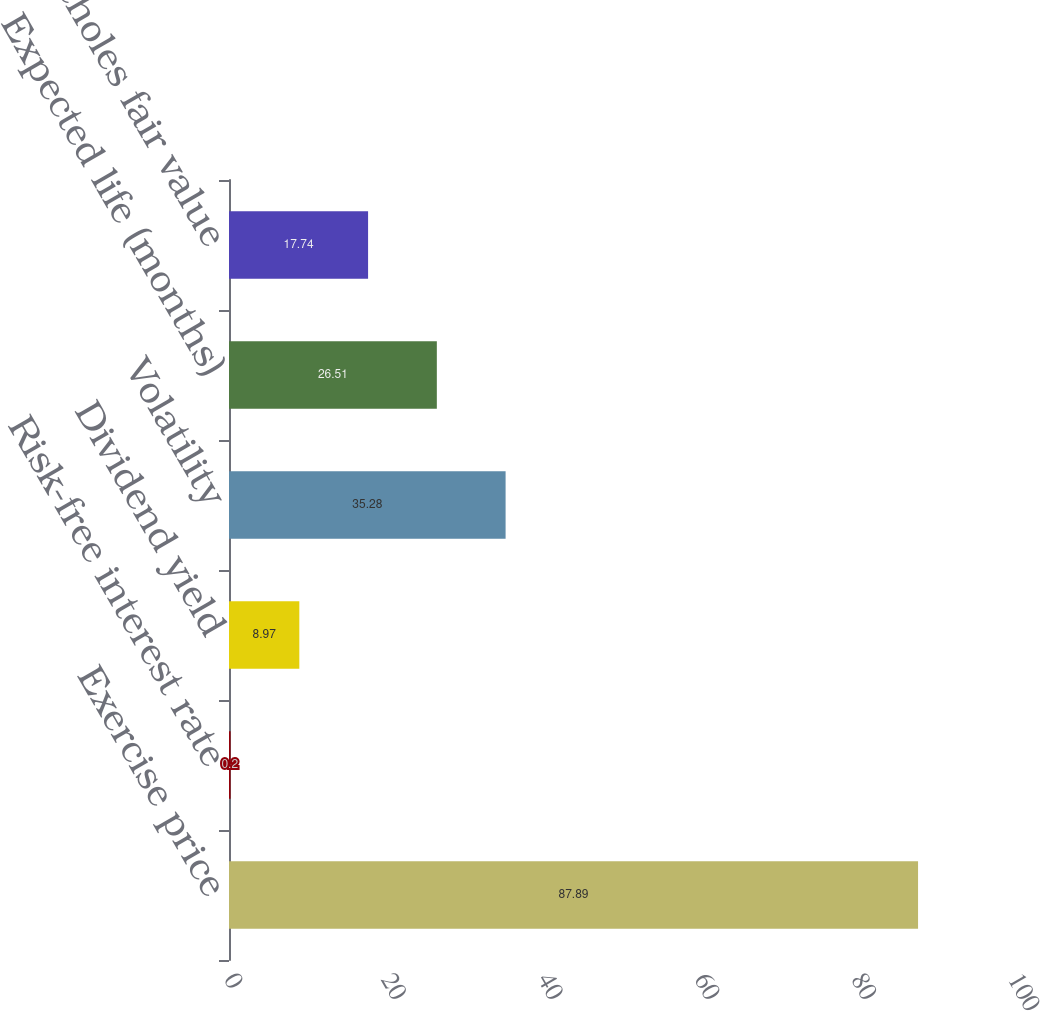Convert chart to OTSL. <chart><loc_0><loc_0><loc_500><loc_500><bar_chart><fcel>Exercise price<fcel>Risk-free interest rate<fcel>Dividend yield<fcel>Volatility<fcel>Expected life (months)<fcel>Black-Scholes fair value<nl><fcel>87.89<fcel>0.2<fcel>8.97<fcel>35.28<fcel>26.51<fcel>17.74<nl></chart> 